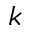<formula> <loc_0><loc_0><loc_500><loc_500>k</formula> 